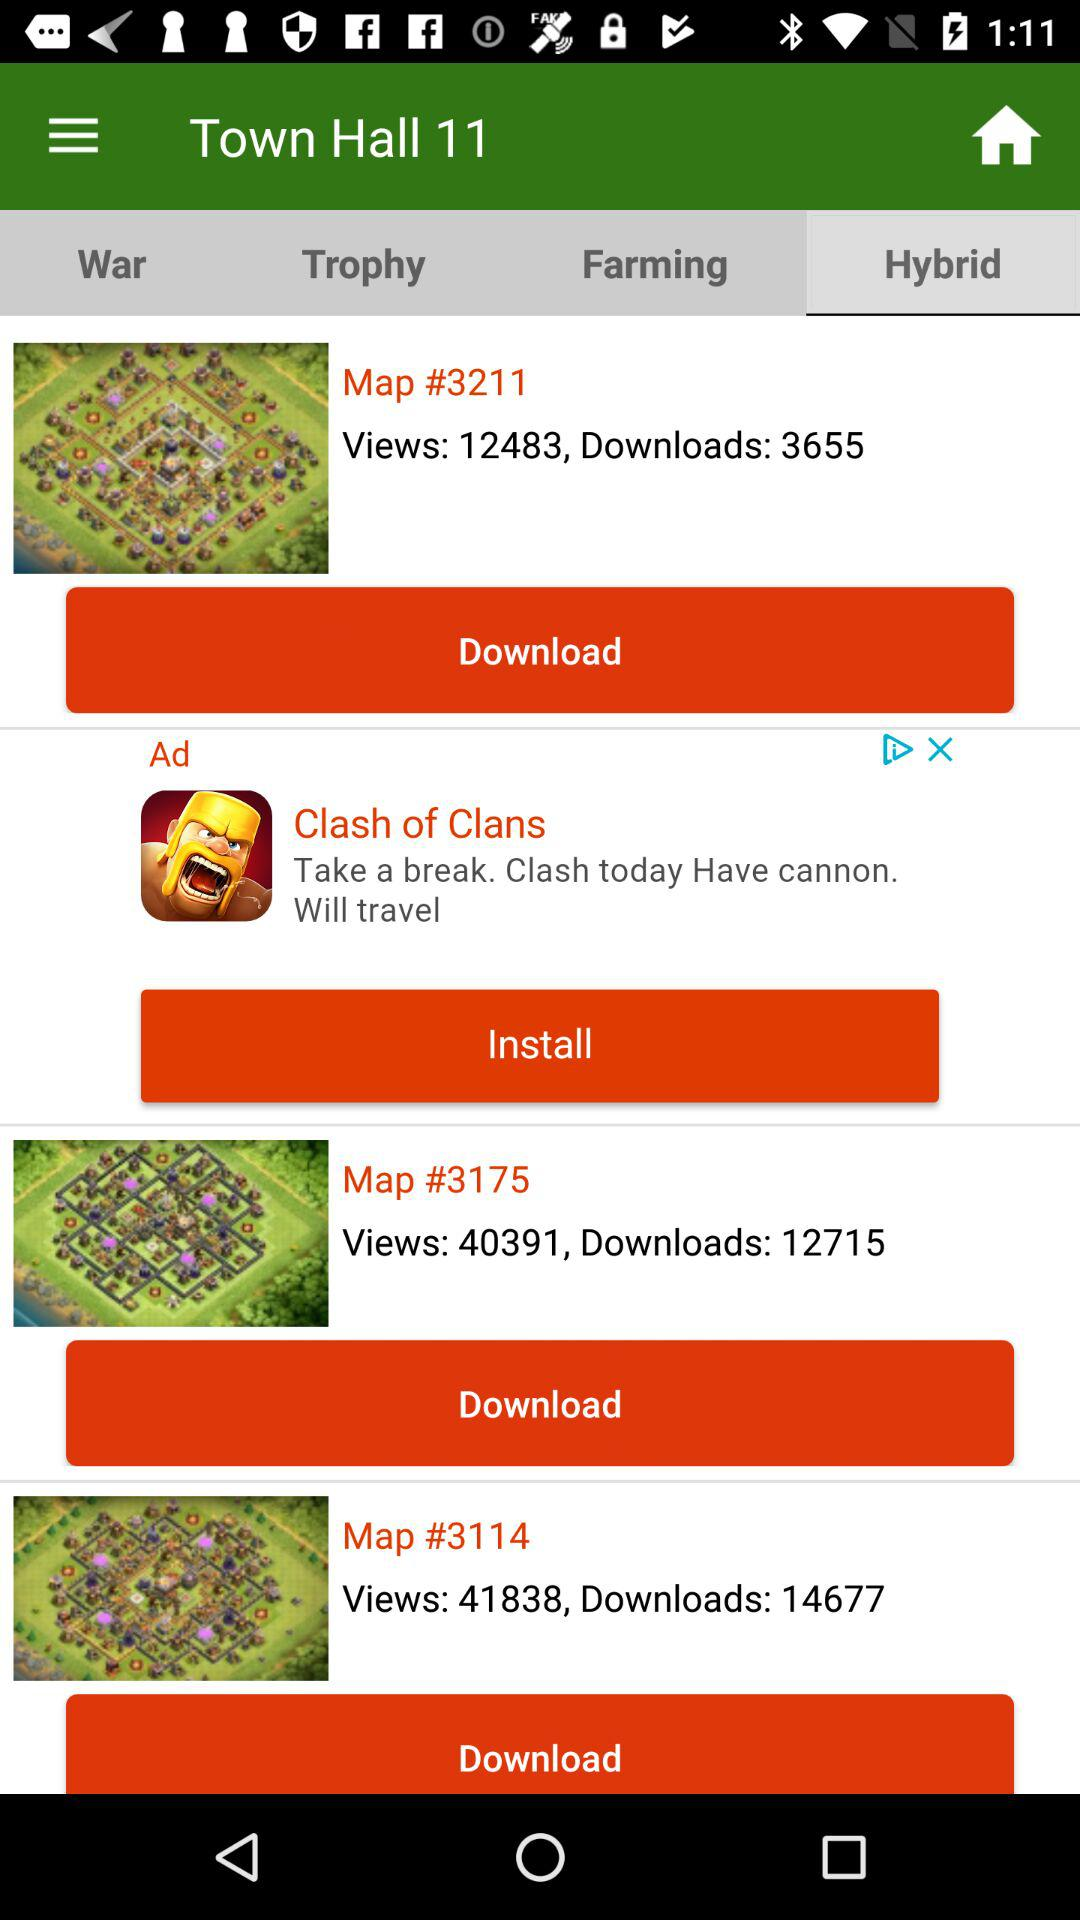Which maps are provided in "Farming"?
When the provided information is insufficient, respond with <no answer>. <no answer> 